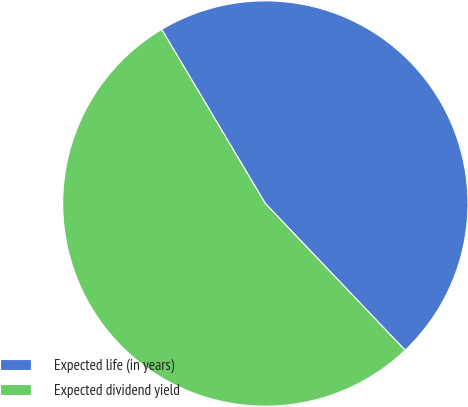Convert chart. <chart><loc_0><loc_0><loc_500><loc_500><pie_chart><fcel>Expected life (in years)<fcel>Expected dividend yield<nl><fcel>46.43%<fcel>53.57%<nl></chart> 